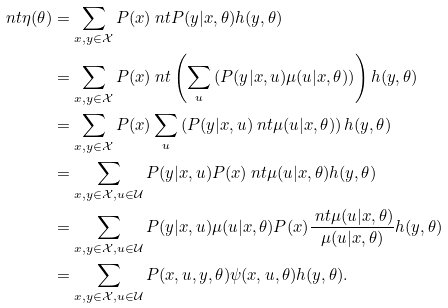<formula> <loc_0><loc_0><loc_500><loc_500>\ n t \eta ( \theta ) & = \sum _ { x , y \in \mathcal { X } } P ( x ) \ n t P ( y | x , \theta ) h ( y , \theta ) \\ & = \sum _ { x , y \in \mathcal { X } } P ( x ) \ n t \left ( \sum _ { u } \left ( P ( y | x , u ) \mu ( u | x , \theta ) \right ) \right ) h ( y , \theta ) \\ & = \sum _ { x , y \in \mathcal { X } } P ( x ) \sum _ { u } \left ( P ( y | x , u ) \ n t \mu ( u | x , \theta ) \right ) h ( y , \theta ) \\ & = \sum _ { x , y \in \mathcal { X } , u \in \mathcal { U } } P ( y | x , u ) P ( x ) \ n t \mu ( u | x , \theta ) h ( y , \theta ) \\ & = \sum _ { x , y \in \mathcal { X } , u \in \mathcal { U } } P ( y | x , u ) \mu ( u | x , \theta ) P ( x ) \frac { \ n t \mu ( u | x , \theta ) } { \mu ( u | x , \theta ) } h ( y , \theta ) \\ & = \sum _ { x , y \in \mathcal { X } , u \in \mathcal { U } } P ( x , u , y , \theta ) \psi ( x , u , \theta ) h ( y , \theta ) .</formula> 